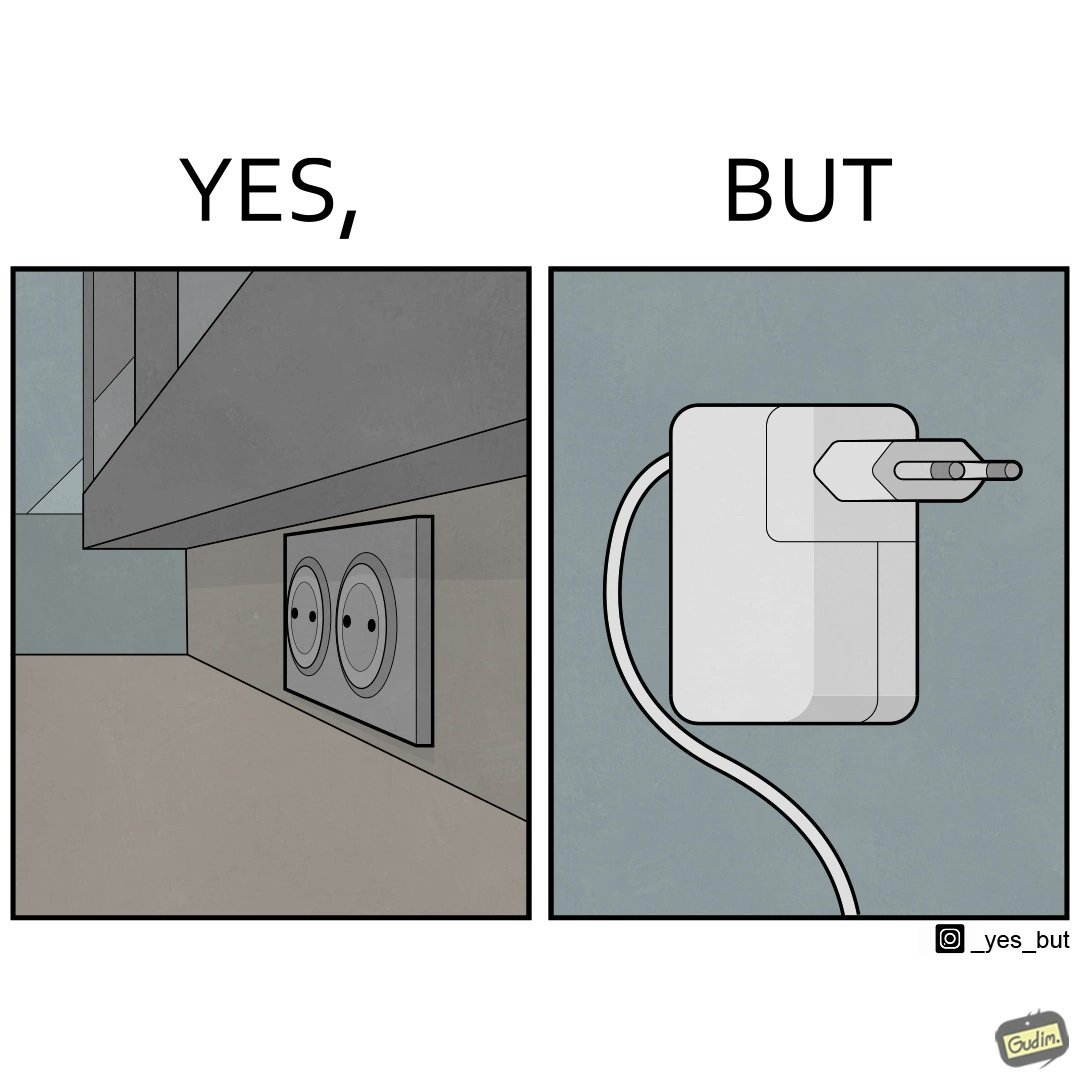What do you see in each half of this image? In the left part of the image: two electrical sockets side by side In the right part of the image: an electrical adapter 